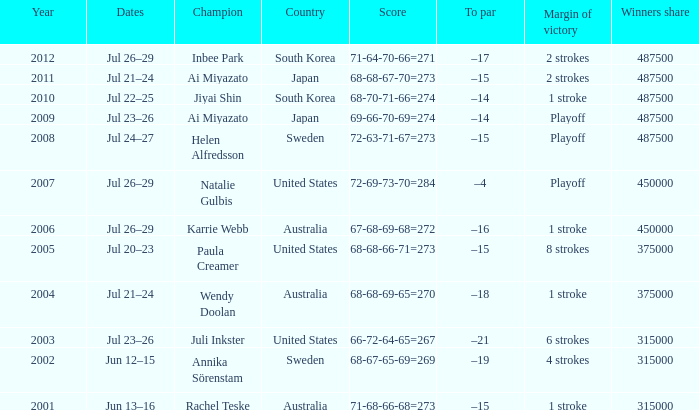How much money is the purse worth when the triumph gap is 8 strokes? 1.0. 